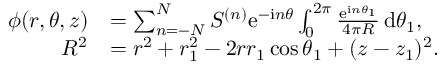<formula> <loc_0><loc_0><loc_500><loc_500>\begin{array} { r l } { \phi ( r , \theta , z ) } & { = \sum _ { n = - N } ^ { N } S ^ { ( n ) } e ^ { - i n \theta } \int _ { 0 } ^ { 2 \pi } \frac { e ^ { i n \theta _ { 1 } } } { 4 \pi R } \, d \theta _ { 1 } , } \\ { R ^ { 2 } } & { = r ^ { 2 } + r _ { 1 } ^ { 2 } - 2 r r _ { 1 } \cos \theta _ { 1 } + ( z - z _ { 1 } ) ^ { 2 } . } \end{array}</formula> 